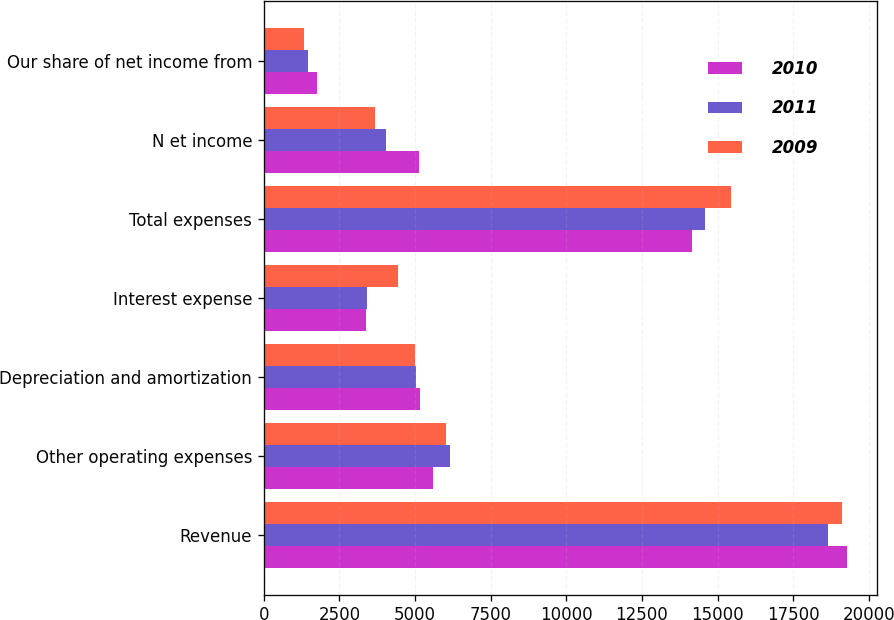<chart> <loc_0><loc_0><loc_500><loc_500><stacked_bar_chart><ecel><fcel>Revenue<fcel>Other operating expenses<fcel>Depreciation and amortization<fcel>Interest expense<fcel>Total expenses<fcel>N et income<fcel>Our share of net income from<nl><fcel>2010<fcel>19289<fcel>5593<fcel>5179<fcel>3388<fcel>14160<fcel>5129<fcel>1771<nl><fcel>2011<fcel>18639<fcel>6149<fcel>5046<fcel>3400<fcel>14595<fcel>4044<fcel>1449<nl><fcel>2009<fcel>19109<fcel>6019<fcel>4998<fcel>4430<fcel>15447<fcel>3662<fcel>1322<nl></chart> 